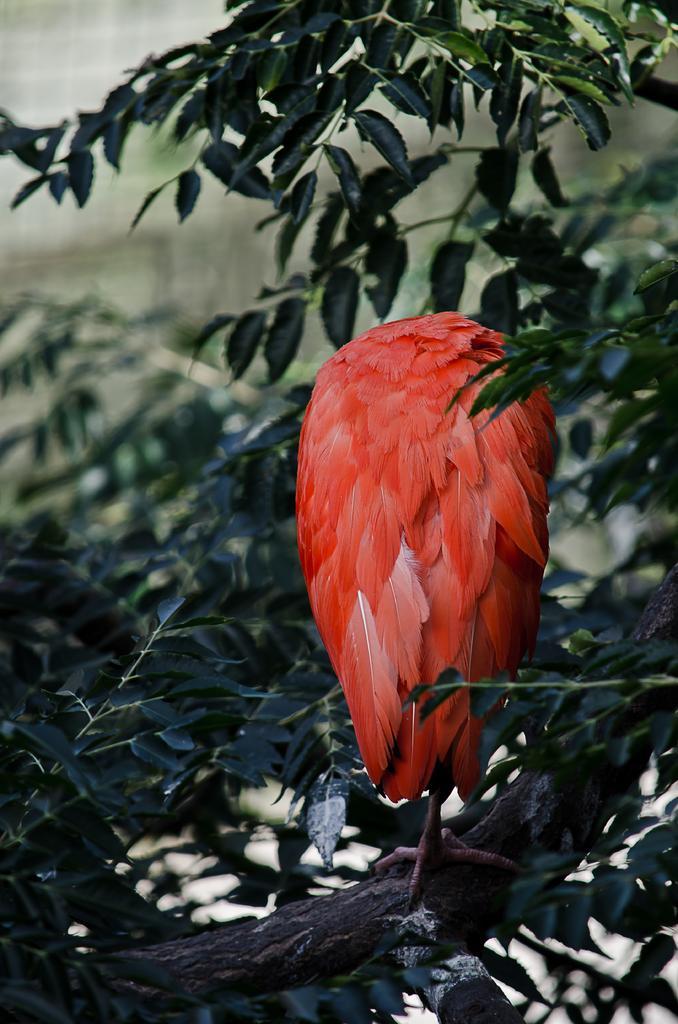How would you summarize this image in a sentence or two? This is the picture of a plant on which there is a bird which has some orange color features. 